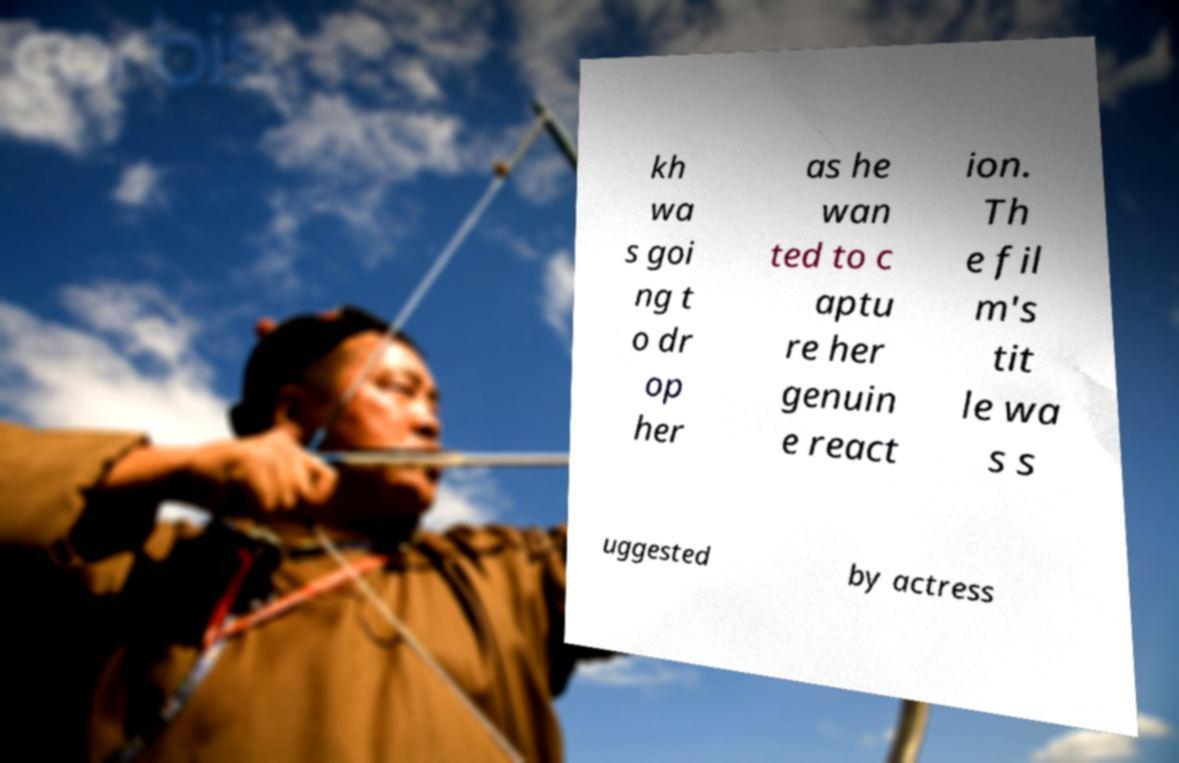Please identify and transcribe the text found in this image. kh wa s goi ng t o dr op her as he wan ted to c aptu re her genuin e react ion. Th e fil m's tit le wa s s uggested by actress 